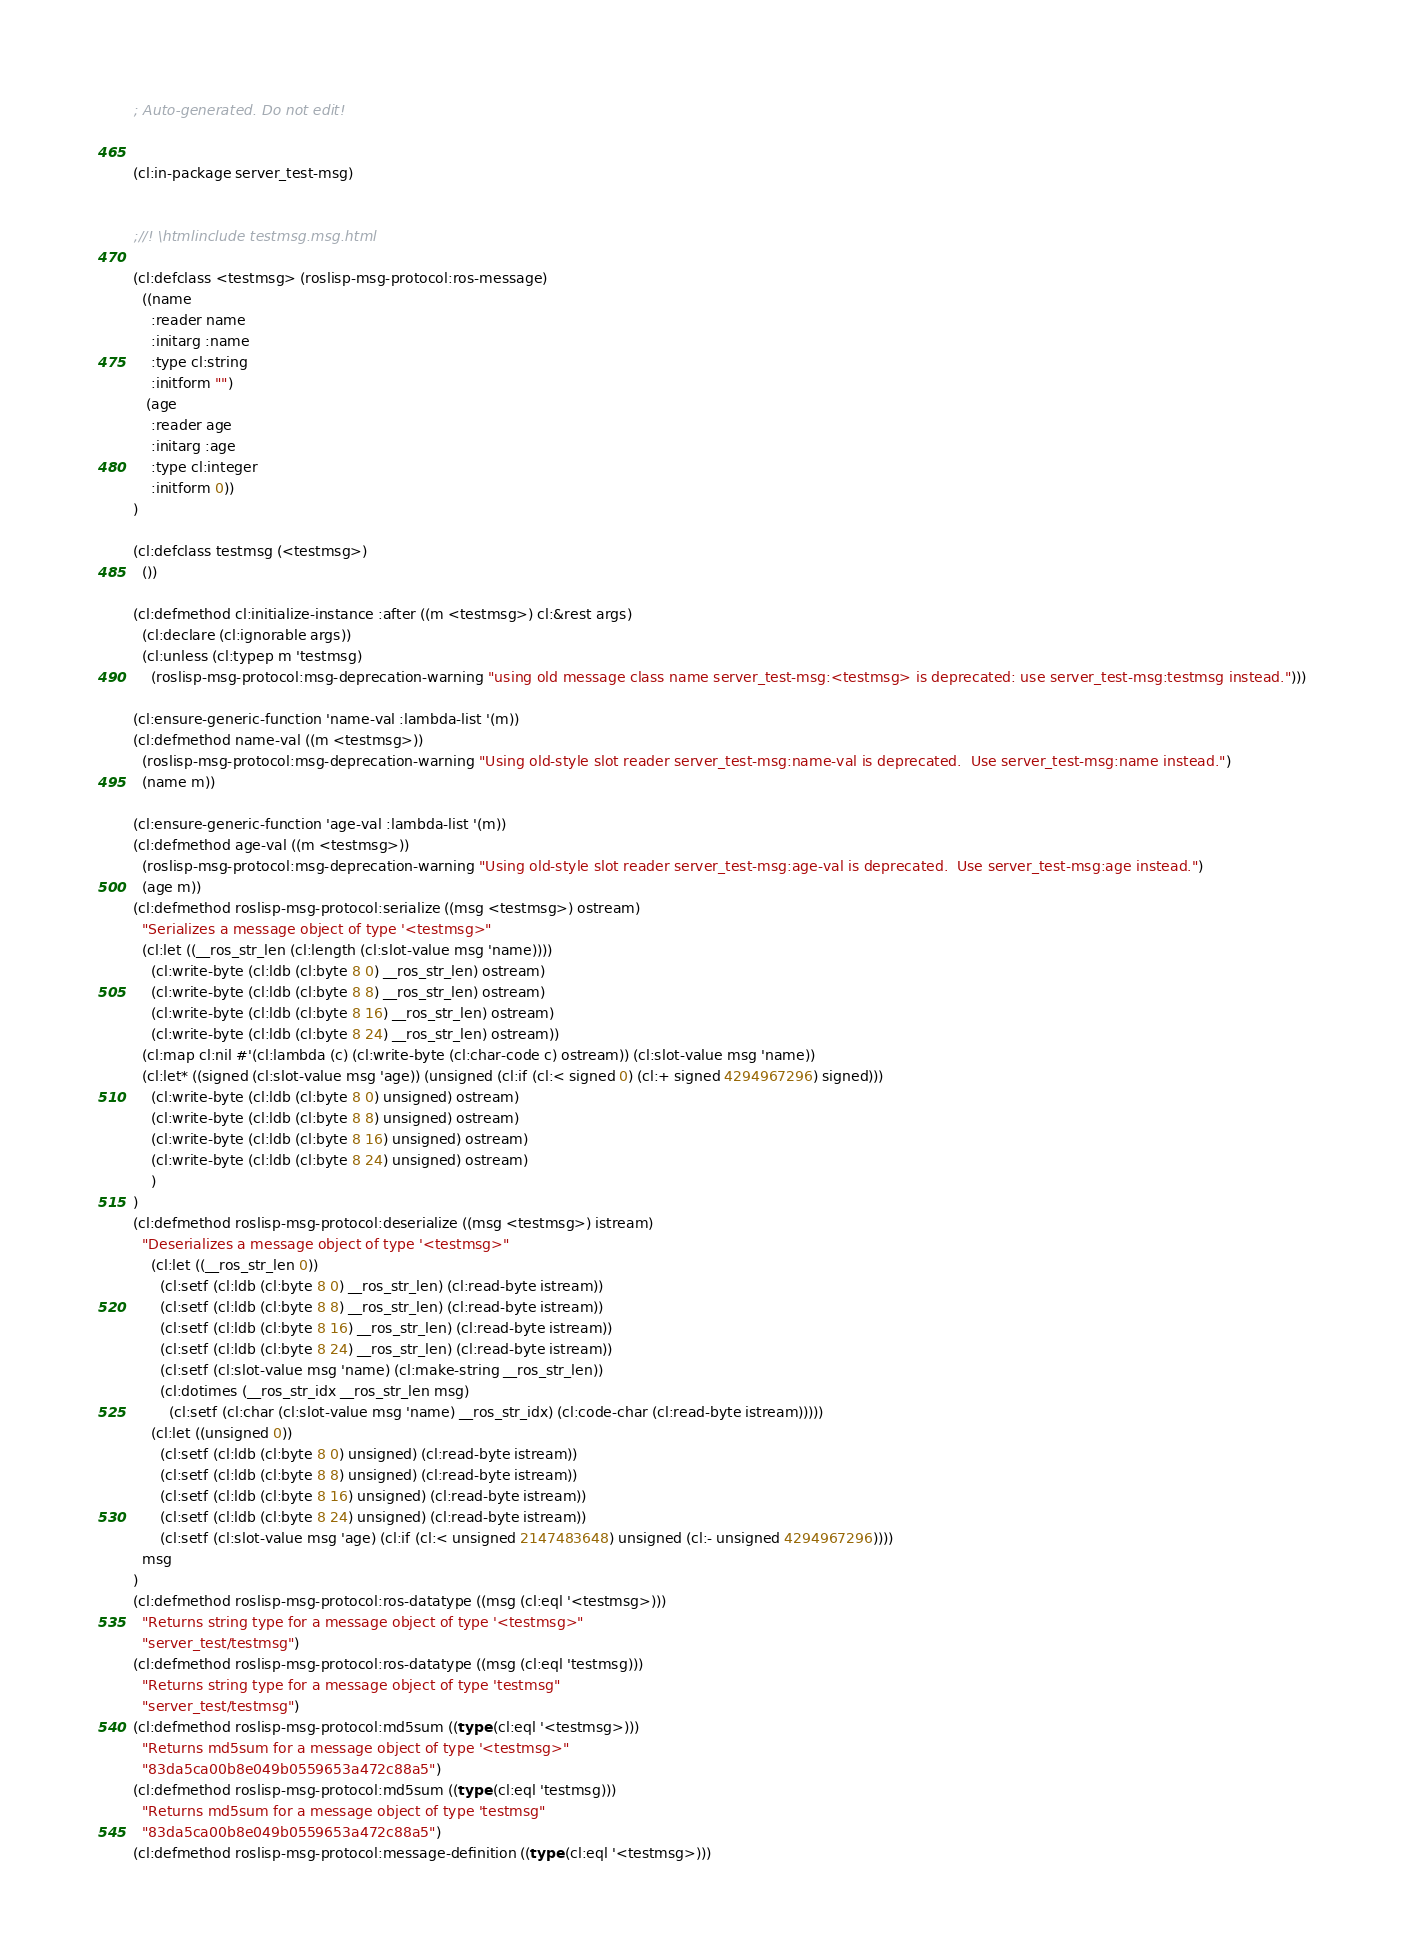<code> <loc_0><loc_0><loc_500><loc_500><_Lisp_>; Auto-generated. Do not edit!


(cl:in-package server_test-msg)


;//! \htmlinclude testmsg.msg.html

(cl:defclass <testmsg> (roslisp-msg-protocol:ros-message)
  ((name
    :reader name
    :initarg :name
    :type cl:string
    :initform "")
   (age
    :reader age
    :initarg :age
    :type cl:integer
    :initform 0))
)

(cl:defclass testmsg (<testmsg>)
  ())

(cl:defmethod cl:initialize-instance :after ((m <testmsg>) cl:&rest args)
  (cl:declare (cl:ignorable args))
  (cl:unless (cl:typep m 'testmsg)
    (roslisp-msg-protocol:msg-deprecation-warning "using old message class name server_test-msg:<testmsg> is deprecated: use server_test-msg:testmsg instead.")))

(cl:ensure-generic-function 'name-val :lambda-list '(m))
(cl:defmethod name-val ((m <testmsg>))
  (roslisp-msg-protocol:msg-deprecation-warning "Using old-style slot reader server_test-msg:name-val is deprecated.  Use server_test-msg:name instead.")
  (name m))

(cl:ensure-generic-function 'age-val :lambda-list '(m))
(cl:defmethod age-val ((m <testmsg>))
  (roslisp-msg-protocol:msg-deprecation-warning "Using old-style slot reader server_test-msg:age-val is deprecated.  Use server_test-msg:age instead.")
  (age m))
(cl:defmethod roslisp-msg-protocol:serialize ((msg <testmsg>) ostream)
  "Serializes a message object of type '<testmsg>"
  (cl:let ((__ros_str_len (cl:length (cl:slot-value msg 'name))))
    (cl:write-byte (cl:ldb (cl:byte 8 0) __ros_str_len) ostream)
    (cl:write-byte (cl:ldb (cl:byte 8 8) __ros_str_len) ostream)
    (cl:write-byte (cl:ldb (cl:byte 8 16) __ros_str_len) ostream)
    (cl:write-byte (cl:ldb (cl:byte 8 24) __ros_str_len) ostream))
  (cl:map cl:nil #'(cl:lambda (c) (cl:write-byte (cl:char-code c) ostream)) (cl:slot-value msg 'name))
  (cl:let* ((signed (cl:slot-value msg 'age)) (unsigned (cl:if (cl:< signed 0) (cl:+ signed 4294967296) signed)))
    (cl:write-byte (cl:ldb (cl:byte 8 0) unsigned) ostream)
    (cl:write-byte (cl:ldb (cl:byte 8 8) unsigned) ostream)
    (cl:write-byte (cl:ldb (cl:byte 8 16) unsigned) ostream)
    (cl:write-byte (cl:ldb (cl:byte 8 24) unsigned) ostream)
    )
)
(cl:defmethod roslisp-msg-protocol:deserialize ((msg <testmsg>) istream)
  "Deserializes a message object of type '<testmsg>"
    (cl:let ((__ros_str_len 0))
      (cl:setf (cl:ldb (cl:byte 8 0) __ros_str_len) (cl:read-byte istream))
      (cl:setf (cl:ldb (cl:byte 8 8) __ros_str_len) (cl:read-byte istream))
      (cl:setf (cl:ldb (cl:byte 8 16) __ros_str_len) (cl:read-byte istream))
      (cl:setf (cl:ldb (cl:byte 8 24) __ros_str_len) (cl:read-byte istream))
      (cl:setf (cl:slot-value msg 'name) (cl:make-string __ros_str_len))
      (cl:dotimes (__ros_str_idx __ros_str_len msg)
        (cl:setf (cl:char (cl:slot-value msg 'name) __ros_str_idx) (cl:code-char (cl:read-byte istream)))))
    (cl:let ((unsigned 0))
      (cl:setf (cl:ldb (cl:byte 8 0) unsigned) (cl:read-byte istream))
      (cl:setf (cl:ldb (cl:byte 8 8) unsigned) (cl:read-byte istream))
      (cl:setf (cl:ldb (cl:byte 8 16) unsigned) (cl:read-byte istream))
      (cl:setf (cl:ldb (cl:byte 8 24) unsigned) (cl:read-byte istream))
      (cl:setf (cl:slot-value msg 'age) (cl:if (cl:< unsigned 2147483648) unsigned (cl:- unsigned 4294967296))))
  msg
)
(cl:defmethod roslisp-msg-protocol:ros-datatype ((msg (cl:eql '<testmsg>)))
  "Returns string type for a message object of type '<testmsg>"
  "server_test/testmsg")
(cl:defmethod roslisp-msg-protocol:ros-datatype ((msg (cl:eql 'testmsg)))
  "Returns string type for a message object of type 'testmsg"
  "server_test/testmsg")
(cl:defmethod roslisp-msg-protocol:md5sum ((type (cl:eql '<testmsg>)))
  "Returns md5sum for a message object of type '<testmsg>"
  "83da5ca00b8e049b0559653a472c88a5")
(cl:defmethod roslisp-msg-protocol:md5sum ((type (cl:eql 'testmsg)))
  "Returns md5sum for a message object of type 'testmsg"
  "83da5ca00b8e049b0559653a472c88a5")
(cl:defmethod roslisp-msg-protocol:message-definition ((type (cl:eql '<testmsg>)))</code> 